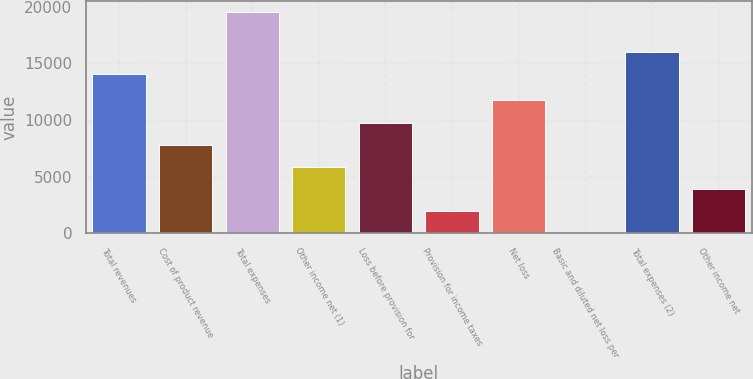<chart> <loc_0><loc_0><loc_500><loc_500><bar_chart><fcel>Total revenues<fcel>Cost of product revenue<fcel>Total expenses<fcel>Other income net (1)<fcel>Loss before provision for<fcel>Provision for income taxes<fcel>Net loss<fcel>Basic and diluted net loss per<fcel>Total expenses (2)<fcel>Other income net<nl><fcel>14063<fcel>7827.74<fcel>19569<fcel>5870.87<fcel>9784.61<fcel>1957.13<fcel>11741.5<fcel>0.26<fcel>16019.9<fcel>3914<nl></chart> 